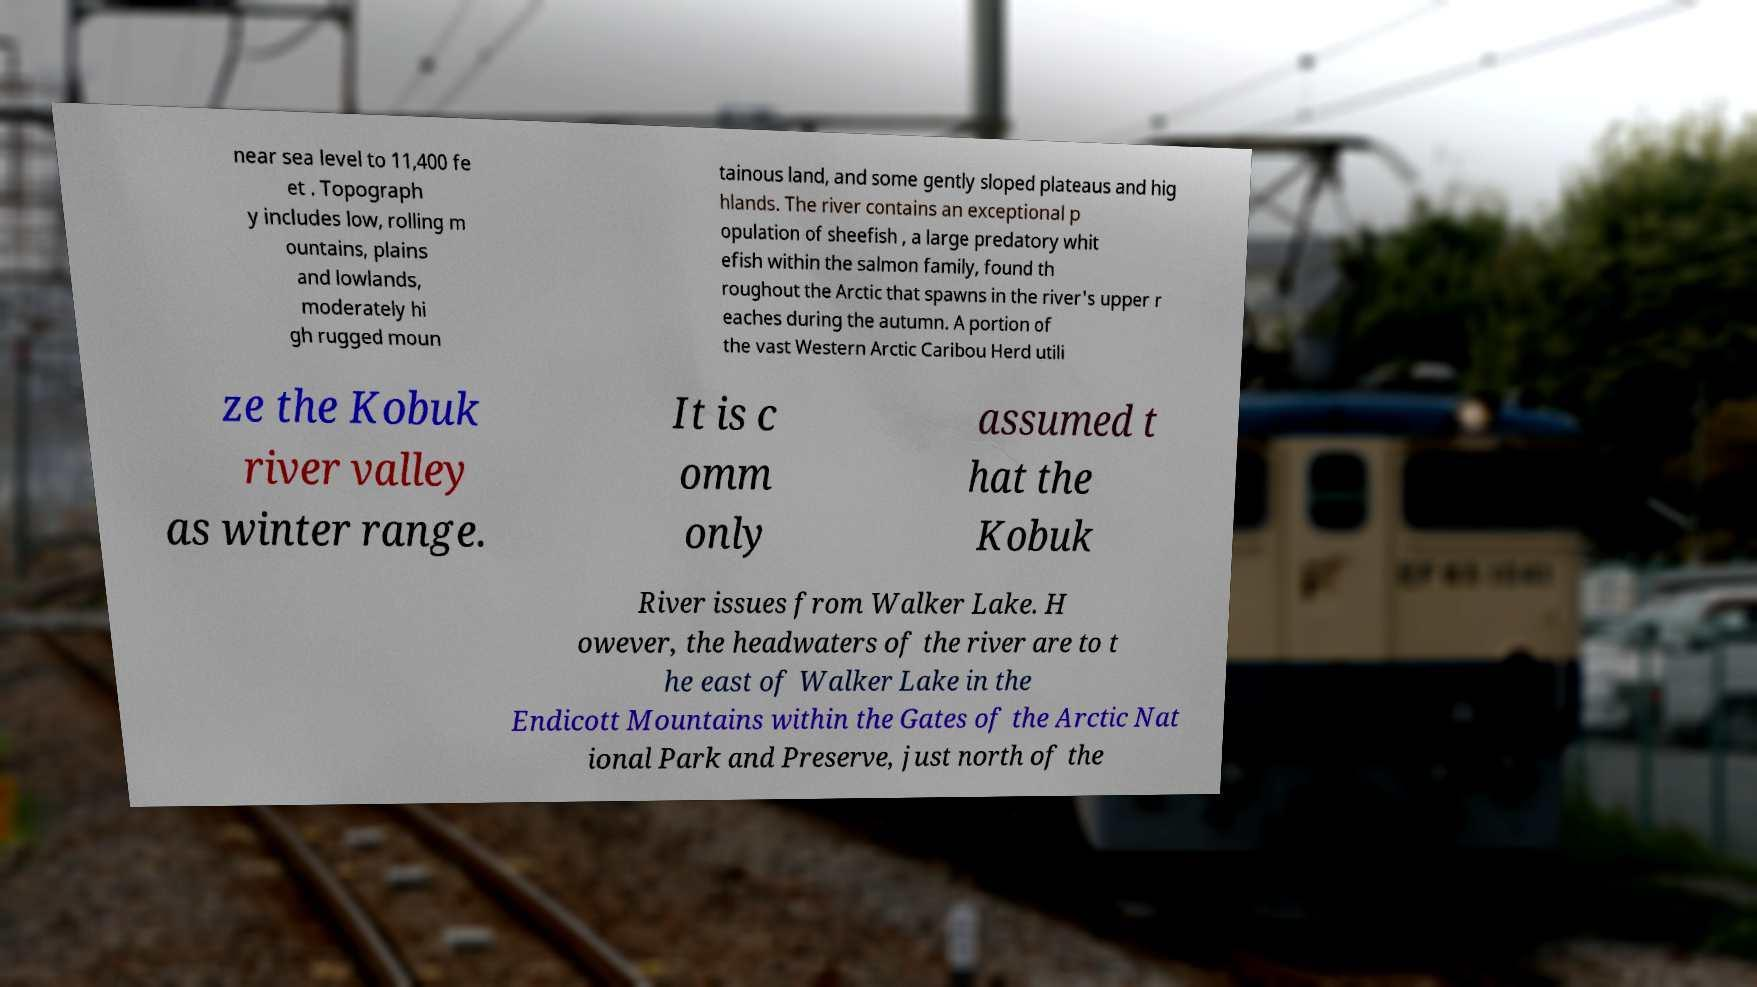There's text embedded in this image that I need extracted. Can you transcribe it verbatim? near sea level to 11,400 fe et . Topograph y includes low, rolling m ountains, plains and lowlands, moderately hi gh rugged moun tainous land, and some gently sloped plateaus and hig hlands. The river contains an exceptional p opulation of sheefish , a large predatory whit efish within the salmon family, found th roughout the Arctic that spawns in the river's upper r eaches during the autumn. A portion of the vast Western Arctic Caribou Herd utili ze the Kobuk river valley as winter range. It is c omm only assumed t hat the Kobuk River issues from Walker Lake. H owever, the headwaters of the river are to t he east of Walker Lake in the Endicott Mountains within the Gates of the Arctic Nat ional Park and Preserve, just north of the 